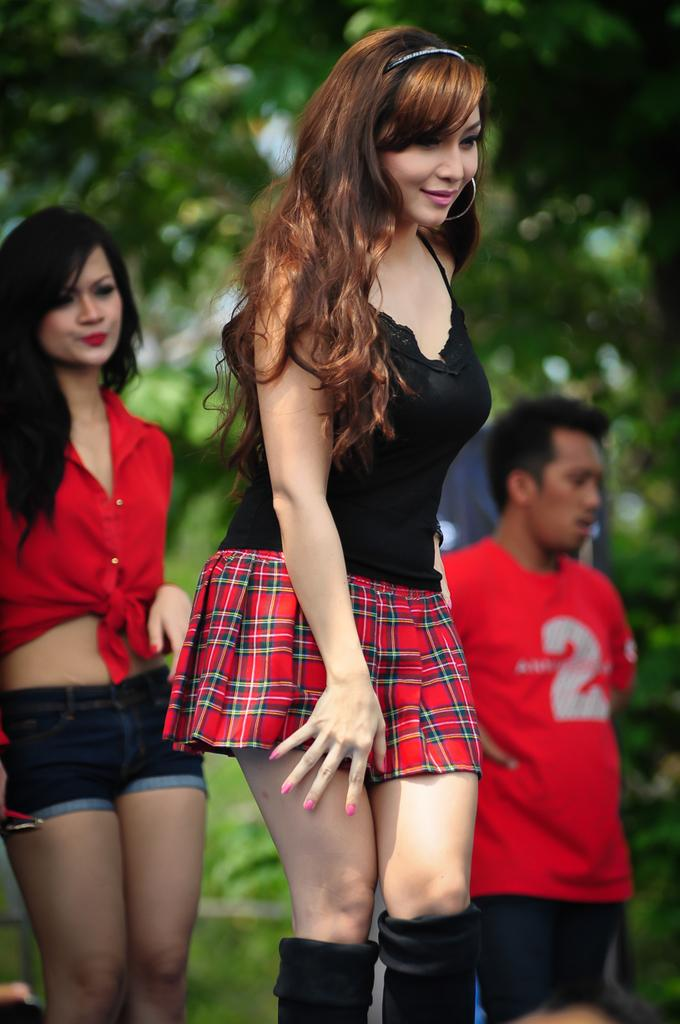How many people are in the image? There are two women and a man in the image. What are the individuals in the image doing? The individuals are standing on the ground. Can you describe the facial expression of the woman in the middle? The woman in the middle is smiling. What type of vegetation can be seen in the background of the image? There are plants and trees visible in the background of the image. How are the trees in the background of the image depicted? The trees in the background of the image appear blurry. What type of mine can be seen in the background of the image? There is no mine present in the image; it features plants, trees, and people. Can you tell me the age of the grandfather in the image? There is no grandfather present in the image, as it features two women and a man. 